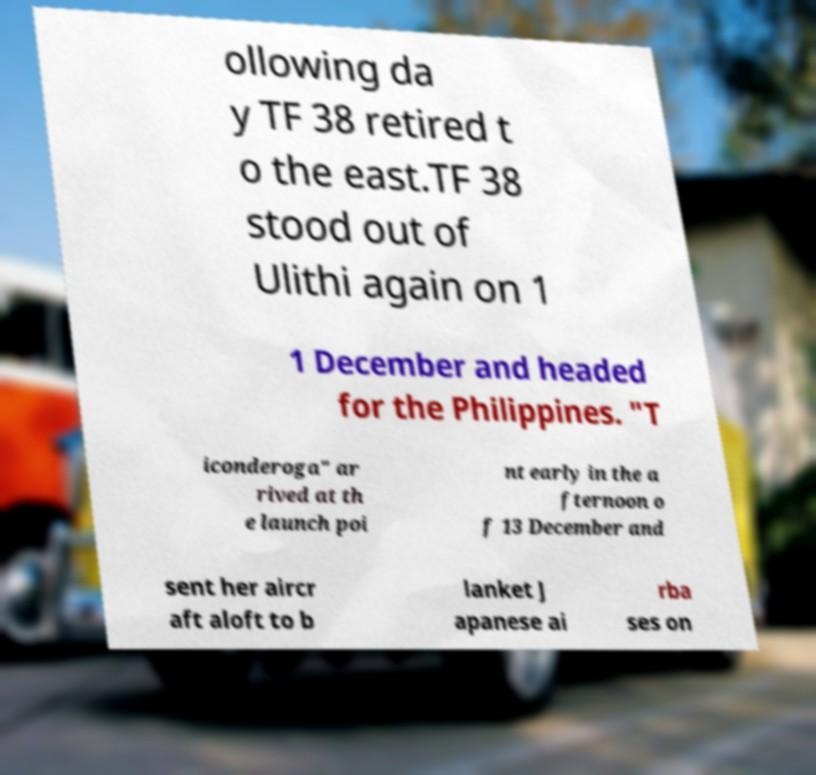There's text embedded in this image that I need extracted. Can you transcribe it verbatim? ollowing da y TF 38 retired t o the east.TF 38 stood out of Ulithi again on 1 1 December and headed for the Philippines. "T iconderoga" ar rived at th e launch poi nt early in the a fternoon o f 13 December and sent her aircr aft aloft to b lanket J apanese ai rba ses on 